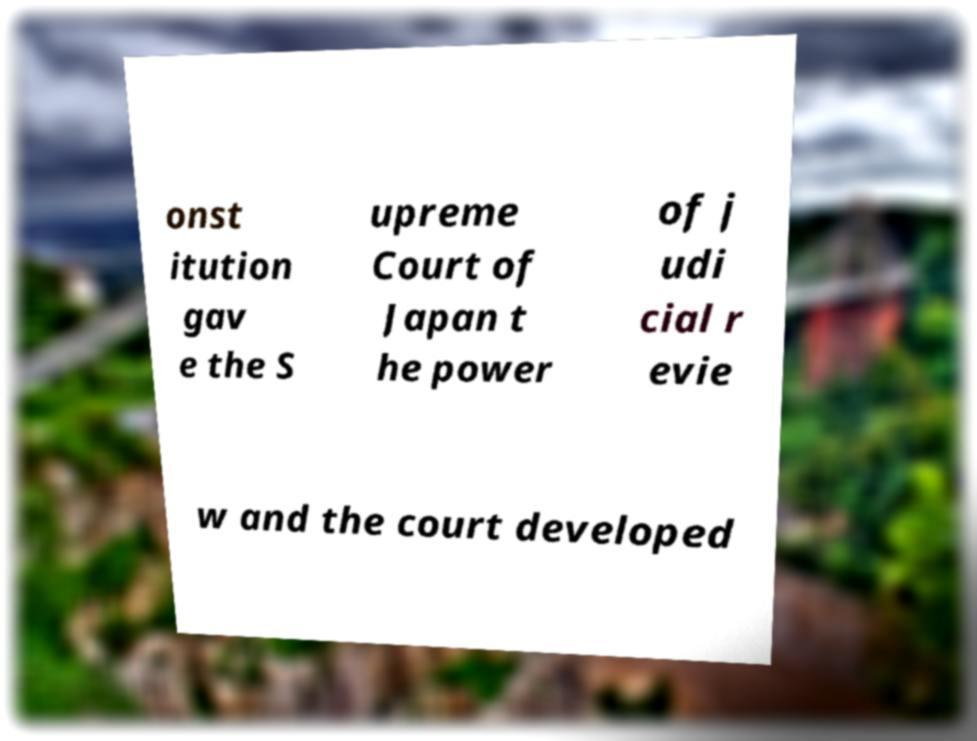What messages or text are displayed in this image? I need them in a readable, typed format. onst itution gav e the S upreme Court of Japan t he power of j udi cial r evie w and the court developed 